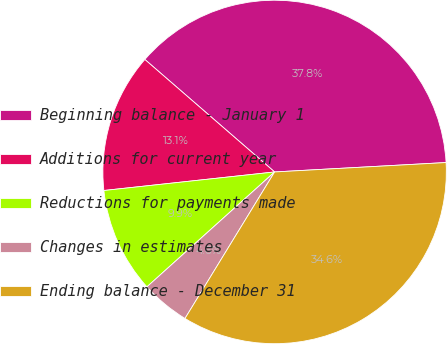Convert chart to OTSL. <chart><loc_0><loc_0><loc_500><loc_500><pie_chart><fcel>Beginning balance - January 1<fcel>Additions for current year<fcel>Reductions for payments made<fcel>Changes in estimates<fcel>Ending balance - December 31<nl><fcel>37.76%<fcel>13.09%<fcel>9.94%<fcel>4.6%<fcel>34.61%<nl></chart> 